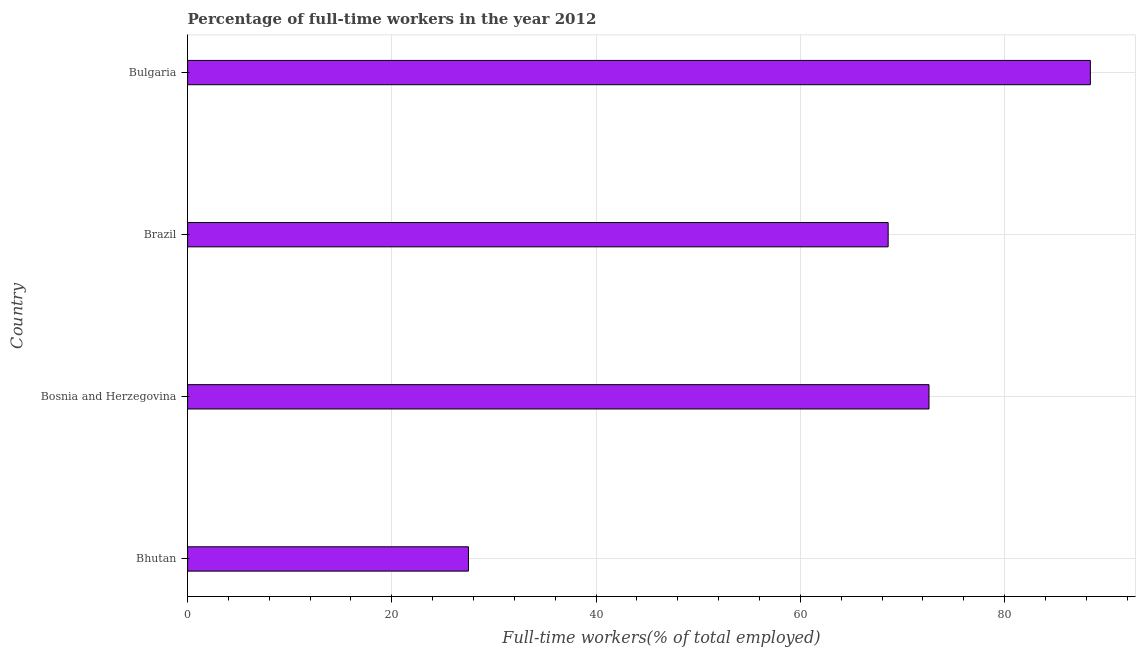Does the graph contain any zero values?
Offer a very short reply. No. What is the title of the graph?
Your answer should be compact. Percentage of full-time workers in the year 2012. What is the label or title of the X-axis?
Offer a very short reply. Full-time workers(% of total employed). What is the label or title of the Y-axis?
Keep it short and to the point. Country. What is the percentage of full-time workers in Bosnia and Herzegovina?
Give a very brief answer. 72.6. Across all countries, what is the maximum percentage of full-time workers?
Offer a very short reply. 88.4. In which country was the percentage of full-time workers minimum?
Offer a terse response. Bhutan. What is the sum of the percentage of full-time workers?
Provide a short and direct response. 257.1. What is the difference between the percentage of full-time workers in Bosnia and Herzegovina and Bulgaria?
Make the answer very short. -15.8. What is the average percentage of full-time workers per country?
Keep it short and to the point. 64.28. What is the median percentage of full-time workers?
Make the answer very short. 70.6. What is the ratio of the percentage of full-time workers in Bosnia and Herzegovina to that in Bulgaria?
Make the answer very short. 0.82. What is the difference between the highest and the lowest percentage of full-time workers?
Provide a short and direct response. 60.9. In how many countries, is the percentage of full-time workers greater than the average percentage of full-time workers taken over all countries?
Your response must be concise. 3. How many bars are there?
Provide a short and direct response. 4. Are all the bars in the graph horizontal?
Make the answer very short. Yes. What is the difference between two consecutive major ticks on the X-axis?
Offer a very short reply. 20. What is the Full-time workers(% of total employed) in Bosnia and Herzegovina?
Give a very brief answer. 72.6. What is the Full-time workers(% of total employed) in Brazil?
Offer a very short reply. 68.6. What is the Full-time workers(% of total employed) of Bulgaria?
Ensure brevity in your answer.  88.4. What is the difference between the Full-time workers(% of total employed) in Bhutan and Bosnia and Herzegovina?
Keep it short and to the point. -45.1. What is the difference between the Full-time workers(% of total employed) in Bhutan and Brazil?
Ensure brevity in your answer.  -41.1. What is the difference between the Full-time workers(% of total employed) in Bhutan and Bulgaria?
Offer a very short reply. -60.9. What is the difference between the Full-time workers(% of total employed) in Bosnia and Herzegovina and Brazil?
Ensure brevity in your answer.  4. What is the difference between the Full-time workers(% of total employed) in Bosnia and Herzegovina and Bulgaria?
Ensure brevity in your answer.  -15.8. What is the difference between the Full-time workers(% of total employed) in Brazil and Bulgaria?
Your answer should be compact. -19.8. What is the ratio of the Full-time workers(% of total employed) in Bhutan to that in Bosnia and Herzegovina?
Your response must be concise. 0.38. What is the ratio of the Full-time workers(% of total employed) in Bhutan to that in Brazil?
Give a very brief answer. 0.4. What is the ratio of the Full-time workers(% of total employed) in Bhutan to that in Bulgaria?
Ensure brevity in your answer.  0.31. What is the ratio of the Full-time workers(% of total employed) in Bosnia and Herzegovina to that in Brazil?
Keep it short and to the point. 1.06. What is the ratio of the Full-time workers(% of total employed) in Bosnia and Herzegovina to that in Bulgaria?
Offer a terse response. 0.82. What is the ratio of the Full-time workers(% of total employed) in Brazil to that in Bulgaria?
Your answer should be compact. 0.78. 